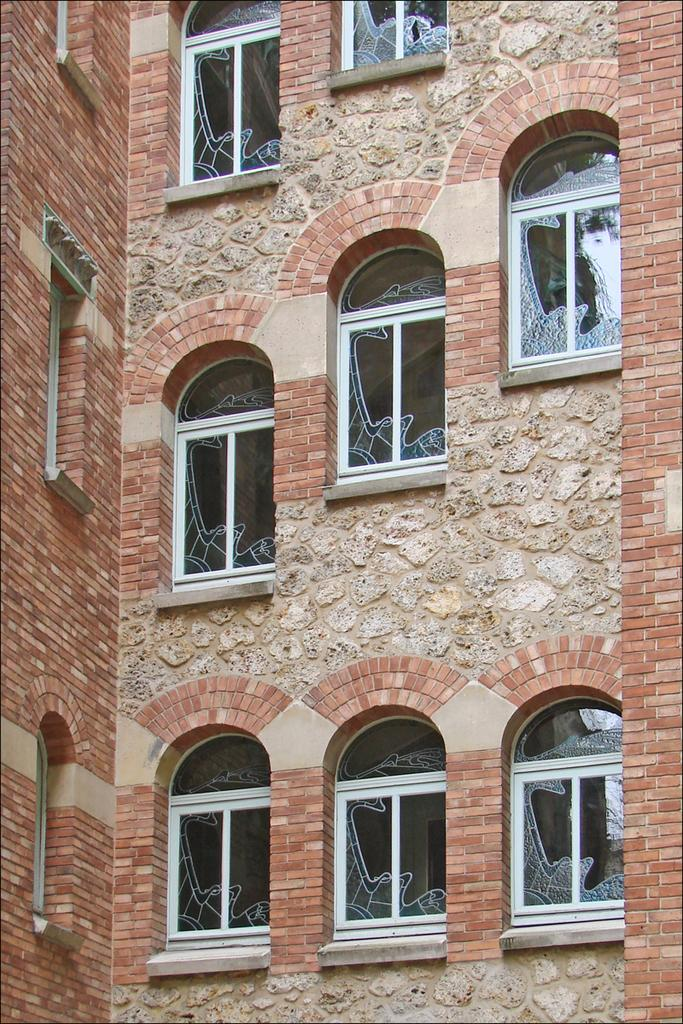What can be seen in the image that provides a view of the outside? There is a window visible in the image. What type of structure does the window belong to? The window is part of a building. What type of alarm is present near the window in the image? There is no alarm present near the window in the image. Is there a scarf hanging on the window in the image? There is no scarf present on the window in the image. 